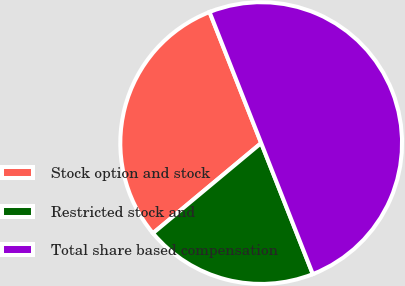<chart> <loc_0><loc_0><loc_500><loc_500><pie_chart><fcel>Stock option and stock<fcel>Restricted stock and<fcel>Total share based compensation<nl><fcel>30.08%<fcel>19.92%<fcel>50.0%<nl></chart> 